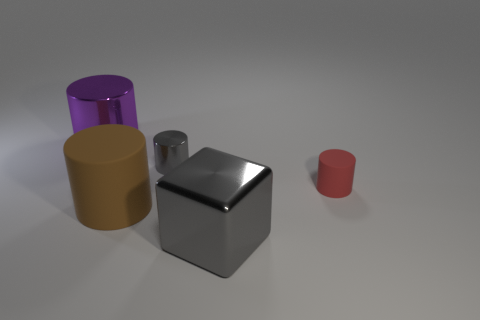There is a metallic block that is the same size as the purple object; what color is it?
Your response must be concise. Gray. Are there any big cyan shiny things that have the same shape as the big purple thing?
Ensure brevity in your answer.  No. There is a matte thing in front of the matte object that is to the right of the thing that is in front of the large matte cylinder; what color is it?
Provide a succinct answer. Brown. How many shiny objects are either tiny cyan cylinders or tiny gray cylinders?
Offer a very short reply. 1. Is the number of gray objects that are behind the small red rubber thing greater than the number of tiny gray things that are on the left side of the large brown object?
Keep it short and to the point. Yes. What number of other things are there of the same size as the red matte object?
Offer a very short reply. 1. There is a gray metal thing that is in front of the rubber cylinder that is right of the small metallic cylinder; what size is it?
Give a very brief answer. Large. How many large objects are gray rubber objects or gray cylinders?
Your response must be concise. 0. What is the size of the rubber cylinder on the left side of the big metallic thing that is in front of the big metal object on the left side of the block?
Give a very brief answer. Large. Is there any other thing that has the same color as the large rubber object?
Make the answer very short. No. 